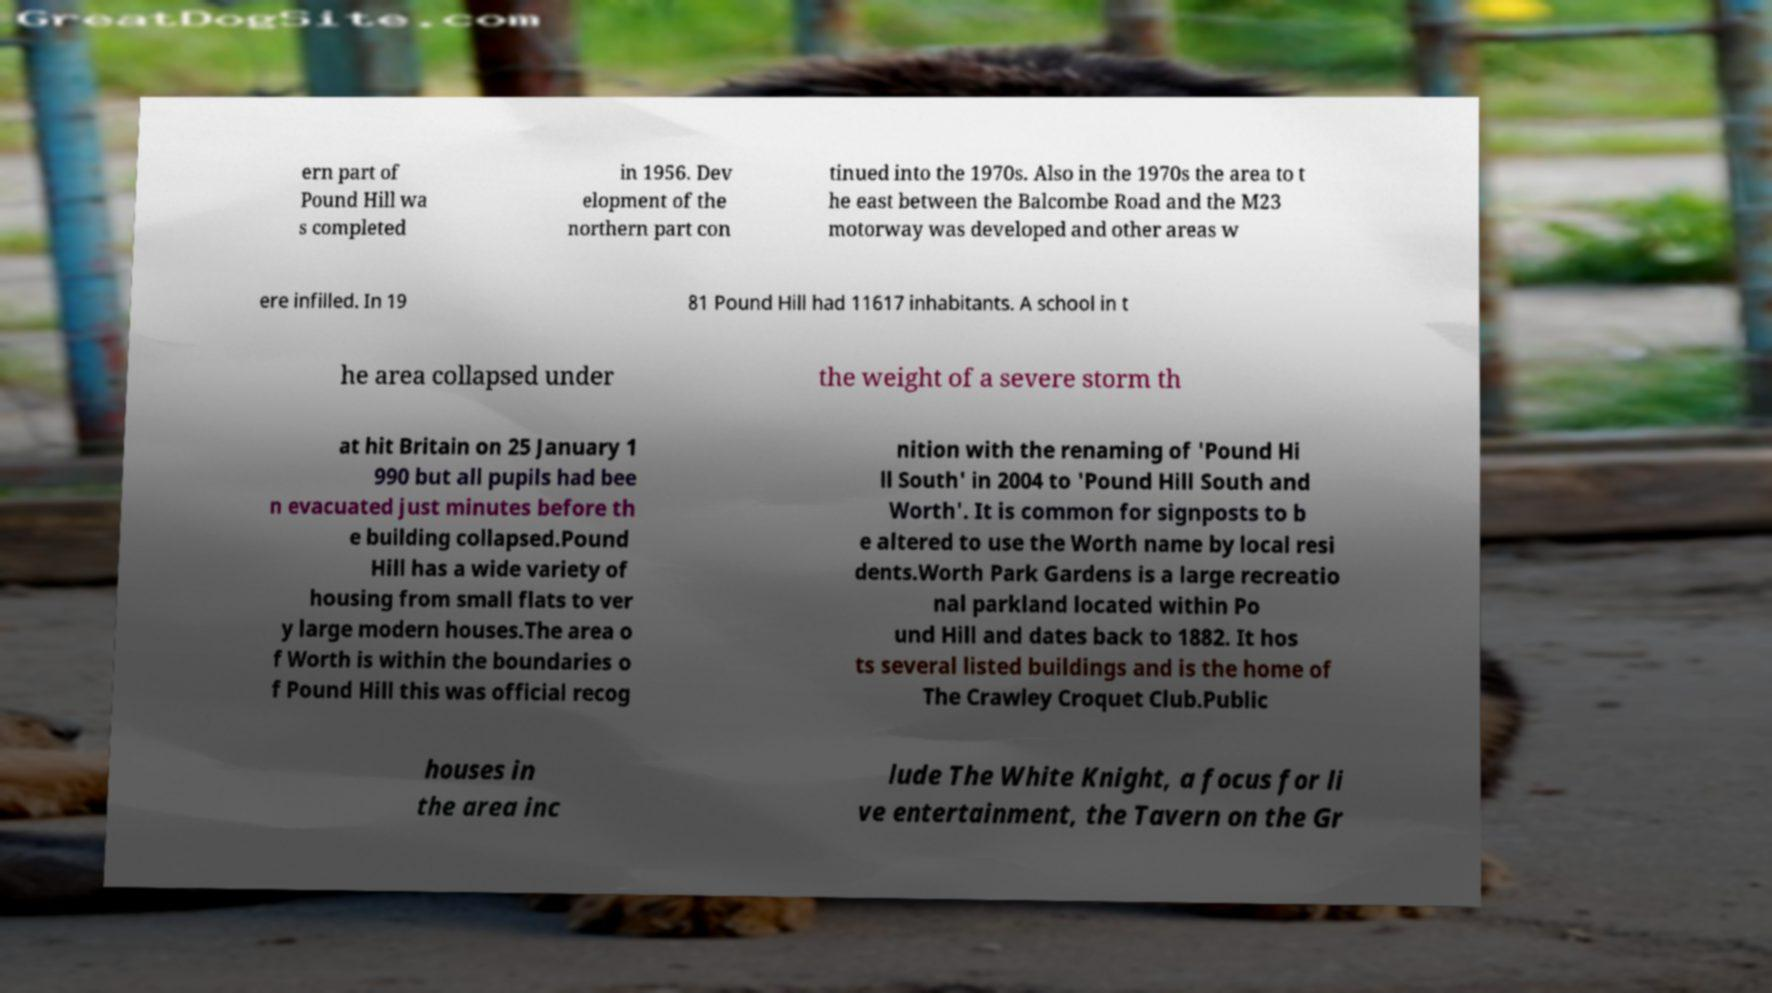Could you extract and type out the text from this image? ern part of Pound Hill wa s completed in 1956. Dev elopment of the northern part con tinued into the 1970s. Also in the 1970s the area to t he east between the Balcombe Road and the M23 motorway was developed and other areas w ere infilled. In 19 81 Pound Hill had 11617 inhabitants. A school in t he area collapsed under the weight of a severe storm th at hit Britain on 25 January 1 990 but all pupils had bee n evacuated just minutes before th e building collapsed.Pound Hill has a wide variety of housing from small flats to ver y large modern houses.The area o f Worth is within the boundaries o f Pound Hill this was official recog nition with the renaming of 'Pound Hi ll South' in 2004 to 'Pound Hill South and Worth'. It is common for signposts to b e altered to use the Worth name by local resi dents.Worth Park Gardens is a large recreatio nal parkland located within Po und Hill and dates back to 1882. It hos ts several listed buildings and is the home of The Crawley Croquet Club.Public houses in the area inc lude The White Knight, a focus for li ve entertainment, the Tavern on the Gr 